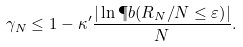Convert formula to latex. <formula><loc_0><loc_0><loc_500><loc_500>\gamma _ { N } \leq 1 - \kappa ^ { \prime } \frac { | \ln { \P b ( R _ { N } / N \leq \varepsilon ) } | } { N } .</formula> 